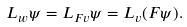Convert formula to latex. <formula><loc_0><loc_0><loc_500><loc_500>L _ { w } \psi = L _ { F v } \psi = L _ { v } ( F \psi ) .</formula> 